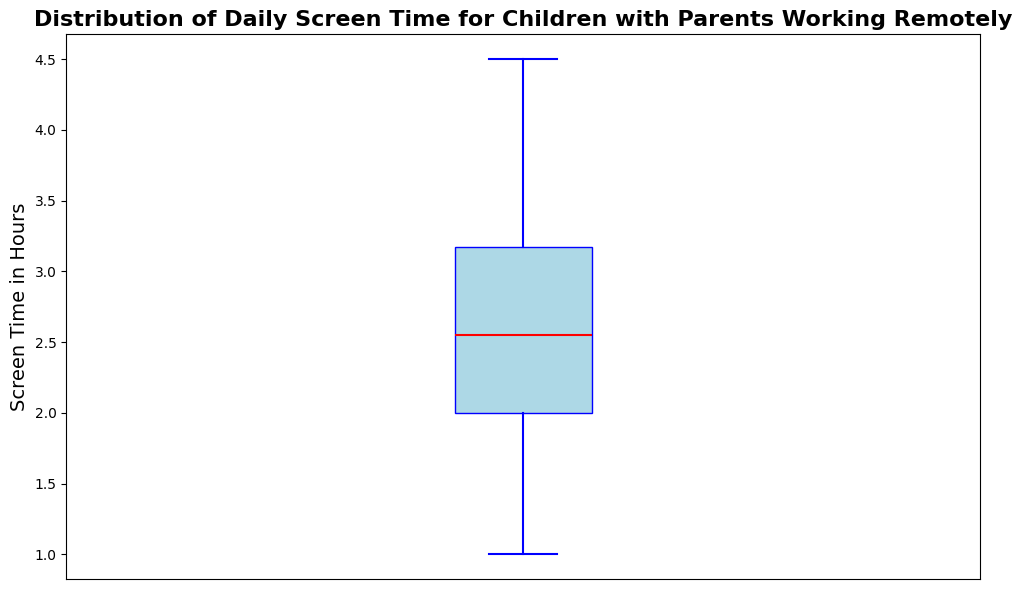What's the median screen time for children? The median is the value that separates the higher half from the lower half of the dataset. In a box plot, it is represented by the red line inside the box.
Answer: 2.5 hours What is the range of screen time for the children? The range is the difference between the maximum and minimum values. The box plot's whiskers show the minimum and maximum values. The minimum value is 1.0 and the maximum value is 4.5, so the range is 4.5 - 1.0.
Answer: 3.5 hours What is the interquartile range (IQR) of the screen time? The IQR is the range between the first quartile (Q1) and the third quartile (Q3). On the box plot, Q1 is the bottom edge of the box and Q3 is the top edge. From the plot, Q1 is approximately 1.8 and Q3 is approximately 3.2. Therefore, IQR is 3.2 - 1.8.
Answer: 1.4 hours How many children have screen time above the median? Since the median is the middle value, half of the children, or 15, would have screen time above the median as represented by the red line in the box plot.
Answer: 15 children What proportion of the children's screen time lies within the interquartile range (IQR)? The IQR represents the middle 50% of the data. This means that 50% of the children's screen time lies within the IQR.
Answer: 50% What's the maximum screen time observed for the children? The maximum value is represented by the top whisker in the box plot.
Answer: 4.5 hours Are there any potential outliers in the screen time data? In a box plot, outliers are typically represented by points beyond the whiskers. There are no individual points shown beyond the whiskers in this box plot, so there are no potential outliers.
Answer: No Which color represents the box in the box plot? The box in the box plot is colored light blue.
Answer: Light blue What does the red line inside the box represent? The red line inside the box represents the median of the screen time data.
Answer: Median Between what values does the middle 50% of the children's screen time fall? The middle 50% or the interquartile range (IQR) falls between the first quartile (Q1) and the third quartile (Q3). From the plot, Q1 is about 1.8 hours and Q3 is about 3.2 hours.
Answer: 1.8 hours to 3.2 hours 